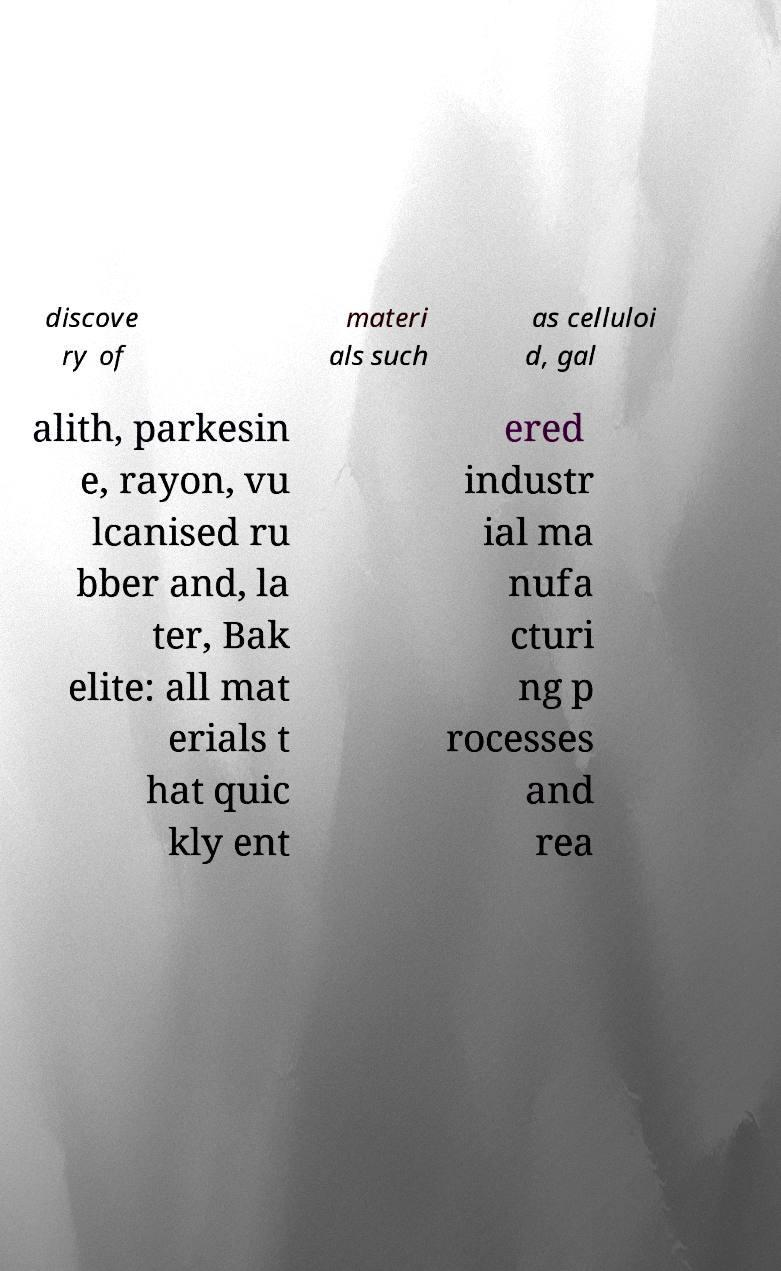Can you accurately transcribe the text from the provided image for me? discove ry of materi als such as celluloi d, gal alith, parkesin e, rayon, vu lcanised ru bber and, la ter, Bak elite: all mat erials t hat quic kly ent ered industr ial ma nufa cturi ng p rocesses and rea 